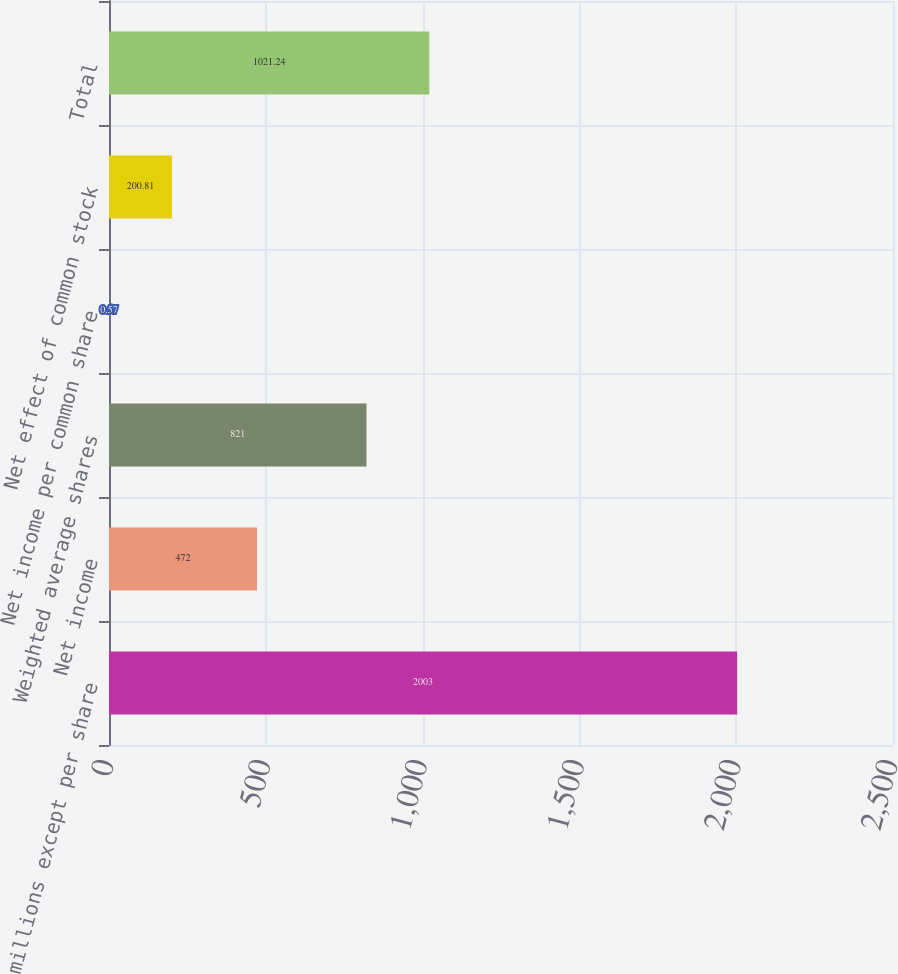<chart> <loc_0><loc_0><loc_500><loc_500><bar_chart><fcel>(in millions except per share<fcel>Net income<fcel>Weighted average shares<fcel>Net income per common share<fcel>Net effect of common stock<fcel>Total<nl><fcel>2003<fcel>472<fcel>821<fcel>0.57<fcel>200.81<fcel>1021.24<nl></chart> 